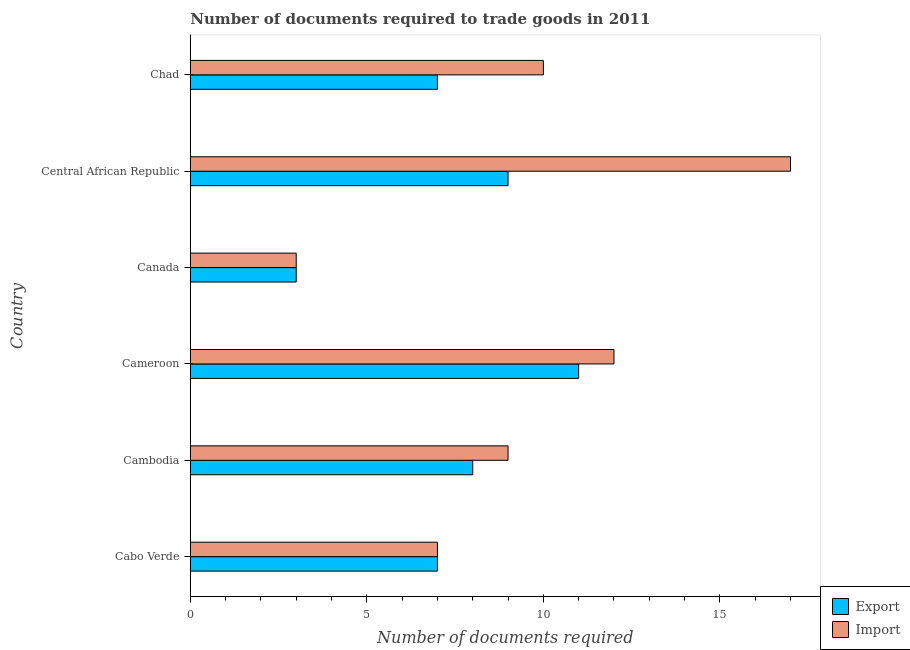How many bars are there on the 2nd tick from the bottom?
Make the answer very short. 2. What is the label of the 5th group of bars from the top?
Keep it short and to the point. Cambodia. In how many cases, is the number of bars for a given country not equal to the number of legend labels?
Keep it short and to the point. 0. What is the number of documents required to import goods in Cambodia?
Provide a succinct answer. 9. Across all countries, what is the maximum number of documents required to import goods?
Provide a succinct answer. 17. In which country was the number of documents required to export goods maximum?
Offer a terse response. Cameroon. What is the difference between the number of documents required to export goods in Chad and the number of documents required to import goods in Cabo Verde?
Keep it short and to the point. 0. What is the average number of documents required to import goods per country?
Ensure brevity in your answer.  9.67. In how many countries, is the number of documents required to export goods greater than 7 ?
Provide a succinct answer. 3. What is the ratio of the number of documents required to export goods in Cambodia to that in Central African Republic?
Your answer should be very brief. 0.89. What is the difference between the highest and the lowest number of documents required to export goods?
Your response must be concise. 8. In how many countries, is the number of documents required to import goods greater than the average number of documents required to import goods taken over all countries?
Your answer should be compact. 3. Is the sum of the number of documents required to import goods in Canada and Central African Republic greater than the maximum number of documents required to export goods across all countries?
Your response must be concise. Yes. What does the 2nd bar from the top in Cameroon represents?
Offer a terse response. Export. What does the 2nd bar from the bottom in Cabo Verde represents?
Ensure brevity in your answer.  Import. How many bars are there?
Your answer should be compact. 12. How many countries are there in the graph?
Provide a short and direct response. 6. What is the difference between two consecutive major ticks on the X-axis?
Keep it short and to the point. 5. Are the values on the major ticks of X-axis written in scientific E-notation?
Your answer should be compact. No. Does the graph contain any zero values?
Offer a very short reply. No. Where does the legend appear in the graph?
Provide a succinct answer. Bottom right. How are the legend labels stacked?
Provide a short and direct response. Vertical. What is the title of the graph?
Provide a short and direct response. Number of documents required to trade goods in 2011. What is the label or title of the X-axis?
Keep it short and to the point. Number of documents required. What is the Number of documents required in Export in Cabo Verde?
Offer a very short reply. 7. What is the Number of documents required of Import in Cabo Verde?
Make the answer very short. 7. What is the Number of documents required in Export in Cameroon?
Your answer should be compact. 11. What is the Number of documents required in Export in Canada?
Provide a succinct answer. 3. What is the Number of documents required in Import in Canada?
Make the answer very short. 3. What is the Number of documents required in Export in Central African Republic?
Your answer should be compact. 9. What is the Number of documents required in Export in Chad?
Offer a terse response. 7. What is the Number of documents required of Import in Chad?
Provide a short and direct response. 10. Across all countries, what is the maximum Number of documents required in Import?
Offer a very short reply. 17. What is the total Number of documents required in Export in the graph?
Offer a very short reply. 45. What is the total Number of documents required of Import in the graph?
Provide a short and direct response. 58. What is the difference between the Number of documents required in Export in Cabo Verde and that in Cambodia?
Provide a succinct answer. -1. What is the difference between the Number of documents required in Export in Cabo Verde and that in Cameroon?
Offer a very short reply. -4. What is the difference between the Number of documents required in Import in Cabo Verde and that in Canada?
Ensure brevity in your answer.  4. What is the difference between the Number of documents required of Export in Cambodia and that in Canada?
Provide a succinct answer. 5. What is the difference between the Number of documents required in Export in Cambodia and that in Central African Republic?
Your response must be concise. -1. What is the difference between the Number of documents required of Import in Cambodia and that in Central African Republic?
Your answer should be compact. -8. What is the difference between the Number of documents required of Import in Cambodia and that in Chad?
Offer a very short reply. -1. What is the difference between the Number of documents required of Export in Cameroon and that in Canada?
Offer a very short reply. 8. What is the difference between the Number of documents required of Import in Cameroon and that in Canada?
Your response must be concise. 9. What is the difference between the Number of documents required of Export in Cameroon and that in Central African Republic?
Give a very brief answer. 2. What is the difference between the Number of documents required in Import in Cameroon and that in Central African Republic?
Your answer should be very brief. -5. What is the difference between the Number of documents required of Export in Cameroon and that in Chad?
Give a very brief answer. 4. What is the difference between the Number of documents required in Import in Cameroon and that in Chad?
Provide a short and direct response. 2. What is the difference between the Number of documents required of Export in Canada and that in Central African Republic?
Offer a very short reply. -6. What is the difference between the Number of documents required in Import in Canada and that in Central African Republic?
Your answer should be compact. -14. What is the difference between the Number of documents required in Export in Canada and that in Chad?
Keep it short and to the point. -4. What is the difference between the Number of documents required of Export in Cabo Verde and the Number of documents required of Import in Cambodia?
Give a very brief answer. -2. What is the difference between the Number of documents required of Export in Cabo Verde and the Number of documents required of Import in Cameroon?
Make the answer very short. -5. What is the difference between the Number of documents required of Export in Cabo Verde and the Number of documents required of Import in Central African Republic?
Provide a succinct answer. -10. What is the difference between the Number of documents required of Export in Cabo Verde and the Number of documents required of Import in Chad?
Your answer should be very brief. -3. What is the difference between the Number of documents required of Export in Cambodia and the Number of documents required of Import in Cameroon?
Ensure brevity in your answer.  -4. What is the difference between the Number of documents required of Export in Cambodia and the Number of documents required of Import in Chad?
Make the answer very short. -2. What is the difference between the Number of documents required of Export in Central African Republic and the Number of documents required of Import in Chad?
Provide a succinct answer. -1. What is the average Number of documents required in Export per country?
Give a very brief answer. 7.5. What is the average Number of documents required in Import per country?
Offer a terse response. 9.67. What is the difference between the Number of documents required of Export and Number of documents required of Import in Cabo Verde?
Make the answer very short. 0. What is the difference between the Number of documents required of Export and Number of documents required of Import in Cambodia?
Offer a terse response. -1. What is the difference between the Number of documents required of Export and Number of documents required of Import in Central African Republic?
Offer a very short reply. -8. What is the ratio of the Number of documents required of Export in Cabo Verde to that in Cameroon?
Your answer should be very brief. 0.64. What is the ratio of the Number of documents required in Import in Cabo Verde to that in Cameroon?
Offer a very short reply. 0.58. What is the ratio of the Number of documents required in Export in Cabo Verde to that in Canada?
Offer a very short reply. 2.33. What is the ratio of the Number of documents required of Import in Cabo Verde to that in Canada?
Your response must be concise. 2.33. What is the ratio of the Number of documents required in Export in Cabo Verde to that in Central African Republic?
Keep it short and to the point. 0.78. What is the ratio of the Number of documents required in Import in Cabo Verde to that in Central African Republic?
Provide a succinct answer. 0.41. What is the ratio of the Number of documents required in Export in Cabo Verde to that in Chad?
Your answer should be very brief. 1. What is the ratio of the Number of documents required of Import in Cabo Verde to that in Chad?
Keep it short and to the point. 0.7. What is the ratio of the Number of documents required of Export in Cambodia to that in Cameroon?
Your answer should be very brief. 0.73. What is the ratio of the Number of documents required of Import in Cambodia to that in Cameroon?
Ensure brevity in your answer.  0.75. What is the ratio of the Number of documents required in Export in Cambodia to that in Canada?
Your response must be concise. 2.67. What is the ratio of the Number of documents required in Import in Cambodia to that in Canada?
Offer a terse response. 3. What is the ratio of the Number of documents required of Import in Cambodia to that in Central African Republic?
Keep it short and to the point. 0.53. What is the ratio of the Number of documents required of Export in Cambodia to that in Chad?
Provide a short and direct response. 1.14. What is the ratio of the Number of documents required of Import in Cambodia to that in Chad?
Your answer should be compact. 0.9. What is the ratio of the Number of documents required of Export in Cameroon to that in Canada?
Your answer should be compact. 3.67. What is the ratio of the Number of documents required of Import in Cameroon to that in Canada?
Keep it short and to the point. 4. What is the ratio of the Number of documents required of Export in Cameroon to that in Central African Republic?
Your response must be concise. 1.22. What is the ratio of the Number of documents required in Import in Cameroon to that in Central African Republic?
Give a very brief answer. 0.71. What is the ratio of the Number of documents required in Export in Cameroon to that in Chad?
Your answer should be very brief. 1.57. What is the ratio of the Number of documents required of Export in Canada to that in Central African Republic?
Offer a very short reply. 0.33. What is the ratio of the Number of documents required in Import in Canada to that in Central African Republic?
Keep it short and to the point. 0.18. What is the ratio of the Number of documents required in Export in Canada to that in Chad?
Your answer should be compact. 0.43. What is the ratio of the Number of documents required of Import in Canada to that in Chad?
Your response must be concise. 0.3. What is the ratio of the Number of documents required in Export in Central African Republic to that in Chad?
Keep it short and to the point. 1.29. What is the difference between the highest and the second highest Number of documents required of Export?
Provide a short and direct response. 2. 